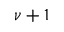Convert formula to latex. <formula><loc_0><loc_0><loc_500><loc_500>\nu + 1</formula> 